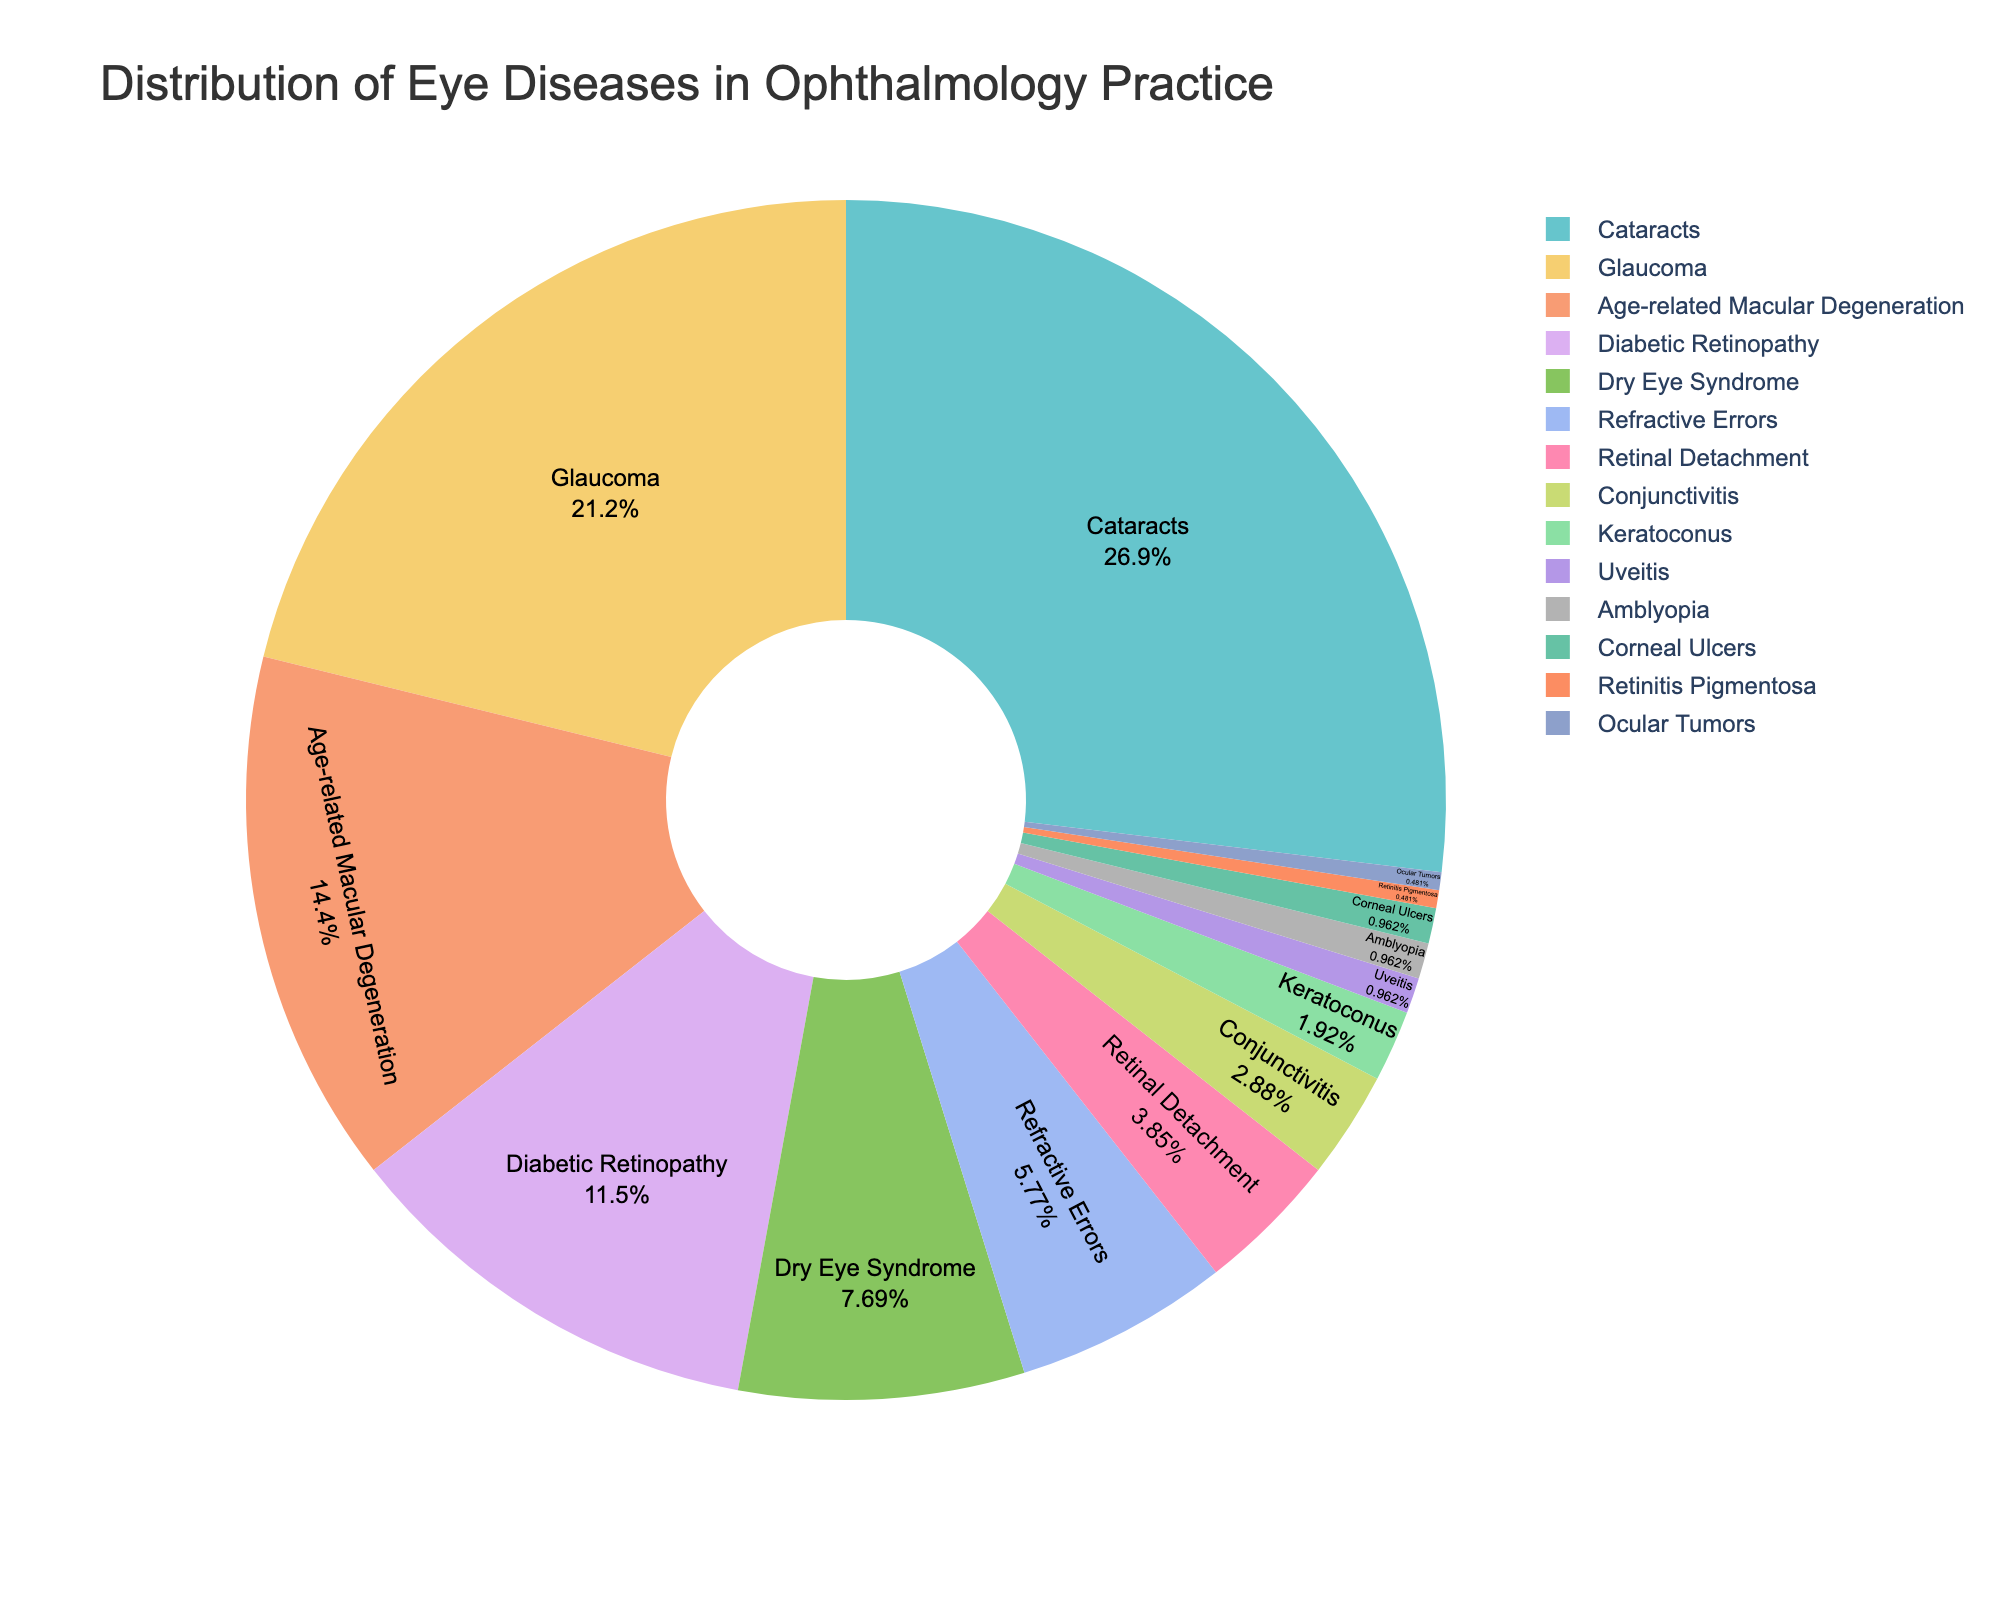What's the most common eye disease treated in this practice? The pie chart shows the percentage distribution of various eye diseases. The slice with the largest percentage represents the most common disease. Cataracts have the highest percentage at 28%.
Answer: Cataracts What is the combined percentage of Cataracts and Glaucoma? From the pie chart, Cataracts are 28% and Glaucoma is 22%. Adding these two percentages gives 28% + 22% = 50%.
Answer: 50% Which eye disease has the lowest treatment percentage according to the chart? The pie chart indicates the smallest slice has the lowest percentage. Uveitis, Amblyopia, Corneal Ulcers, Retinitis Pigmentosa, and Ocular Tumors all each have 0.5% or 1%, but Retinitis Pigmentosa and Ocular Tumors specifically have the lowest at 0.5% each.
Answer: Retinitis Pigmentosa and Ocular Tumors How much more common are Cataracts than Refractive Errors? The pie chart shows Cataracts at 28% and Refractive Errors at 6%. Subtracting these percentages gives 28% - 6% = 22%.
Answer: 22% Are Age-related Macular Degeneration treatments more common than Diabetic Retinopathy treatments? From the pie chart, Age-related Macular Degeneration is 15% while Diabetic Retinopathy is 12%. Since 15% is greater than 12%, Age-related Macular Degeneration treatments are more common.
Answer: Yes What percentage of treatments is attributed to Dry Eye Syndrome and Refractive Errors combined? Dry Eye Syndrome is 8% and Refractive Errors are 6%. Adding these percentages gives 8% + 6% = 14%.
Answer: 14% Which is greater, the sum of Cataracts and Age-related Macular Degeneration treatments or the sum of Glaucoma and Diabetic Retinopathy treatments? Cataracts are 28% and Age-related Macular Degeneration is 15%, summing to 28% + 15% = 43%. Glaucoma is 22% and Diabetic Retinopathy is 12%, summing to 22% + 12% = 34%. Comparing 43% to 34%, Cataracts and Age-related Macular Degeneration sum is greater.
Answer: Cataracts and Age-related Macular Degeneration Between Retinal Detachment and Conjunctivitis, which has a smaller treatment percentage? The pie chart shows Retinal Detachment at 4% and Conjunctivitis at 3%, so Conjunctivitis has a smaller treatment percentage.
Answer: Conjunctivitis What is the proportion of treatments for Glaucoma to Retinal Detachment? Glaucoma is 22% and Retinal Detachment is 4%. The ratio is 22% / 4%, which simplifies to approximately 5.5.
Answer: ~5.5 If the percentage for Corneal Ulcers doubled, what would the new percentage be? Currently, Corneal Ulcers is 1%. Doubling this means multiplying by 2, resulting in 1% * 2 = 2%.
Answer: 2% 